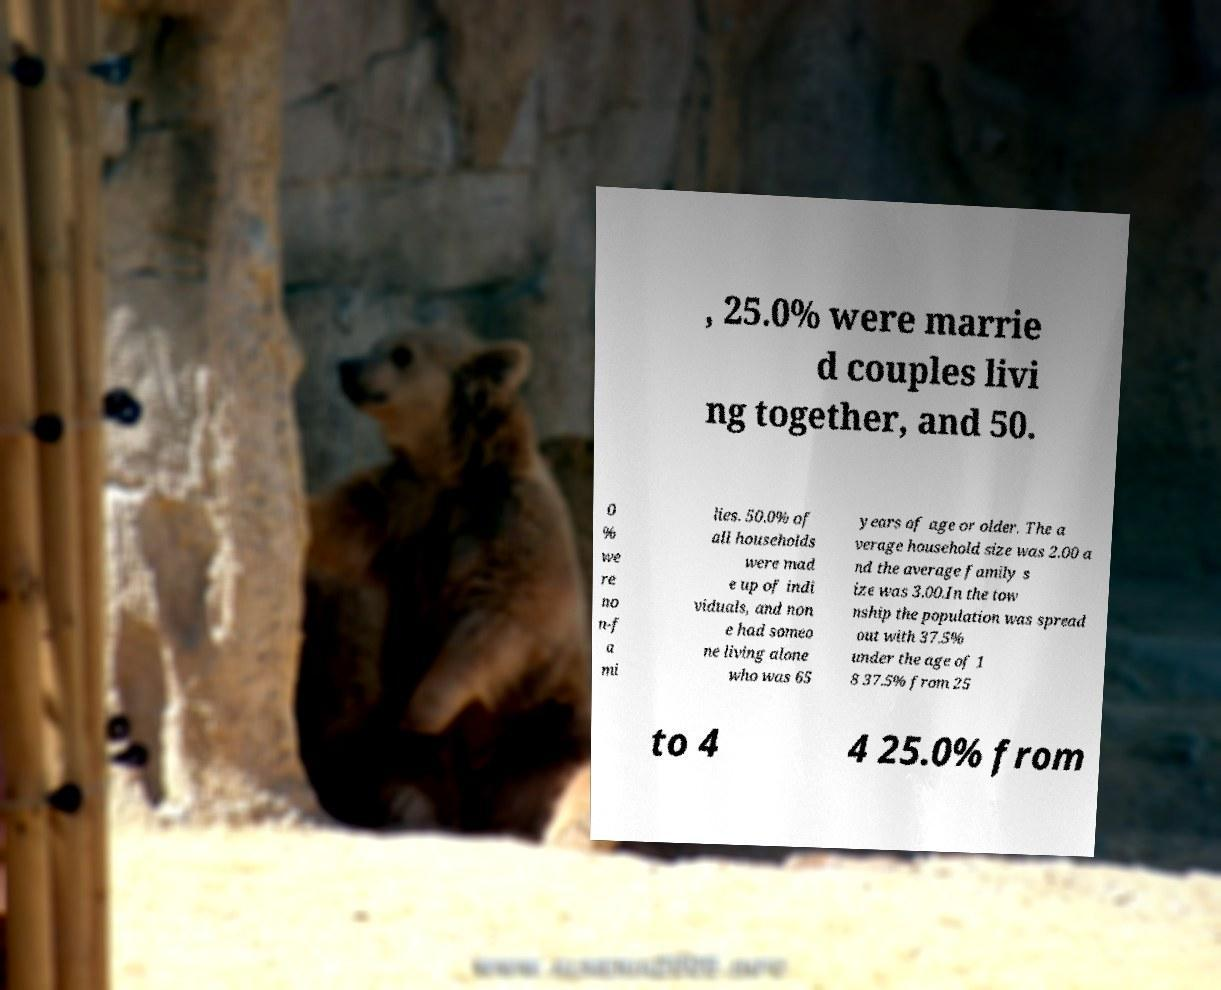Could you extract and type out the text from this image? , 25.0% were marrie d couples livi ng together, and 50. 0 % we re no n-f a mi lies. 50.0% of all households were mad e up of indi viduals, and non e had someo ne living alone who was 65 years of age or older. The a verage household size was 2.00 a nd the average family s ize was 3.00.In the tow nship the population was spread out with 37.5% under the age of 1 8 37.5% from 25 to 4 4 25.0% from 